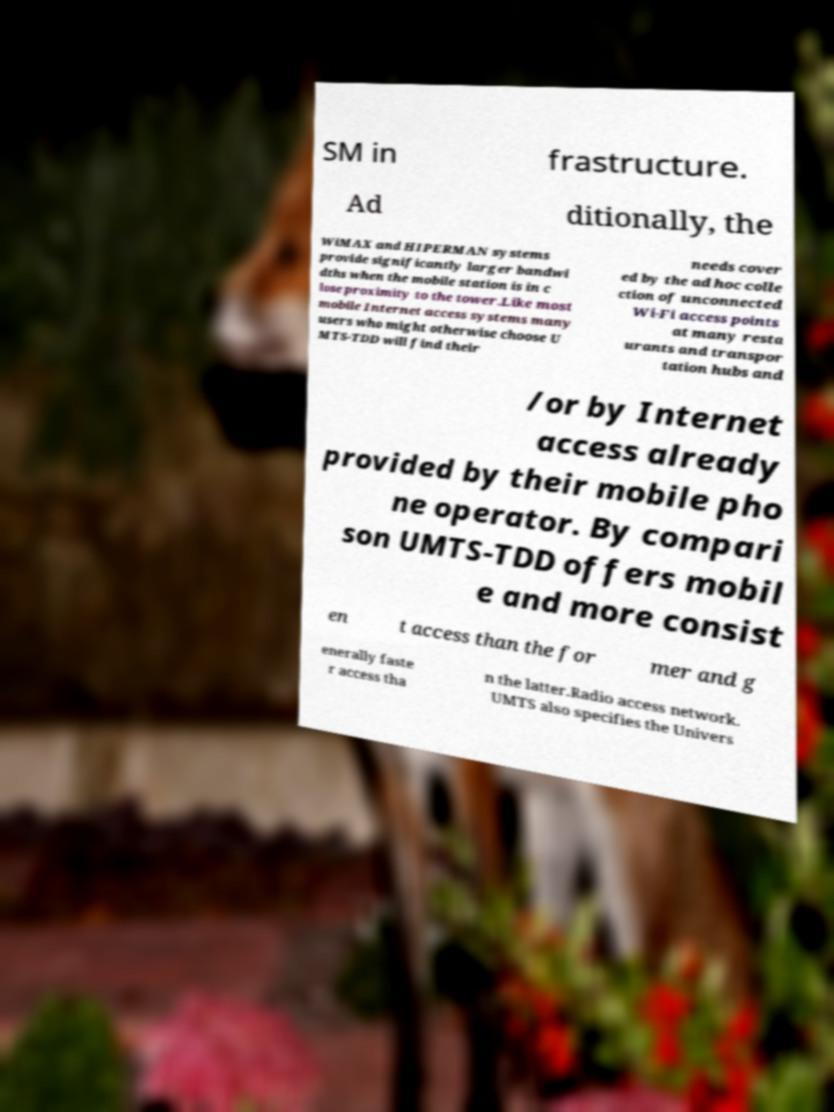Could you extract and type out the text from this image? SM in frastructure. Ad ditionally, the WiMAX and HIPERMAN systems provide significantly larger bandwi dths when the mobile station is in c lose proximity to the tower.Like most mobile Internet access systems many users who might otherwise choose U MTS-TDD will find their needs cover ed by the ad hoc colle ction of unconnected Wi-Fi access points at many resta urants and transpor tation hubs and /or by Internet access already provided by their mobile pho ne operator. By compari son UMTS-TDD offers mobil e and more consist en t access than the for mer and g enerally faste r access tha n the latter.Radio access network. UMTS also specifies the Univers 